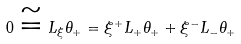<formula> <loc_0><loc_0><loc_500><loc_500>0 \cong L _ { \xi } \theta _ { + } = \xi ^ { + } L _ { + } \theta _ { + } + \xi ^ { - } L _ { - } \theta _ { + }</formula> 